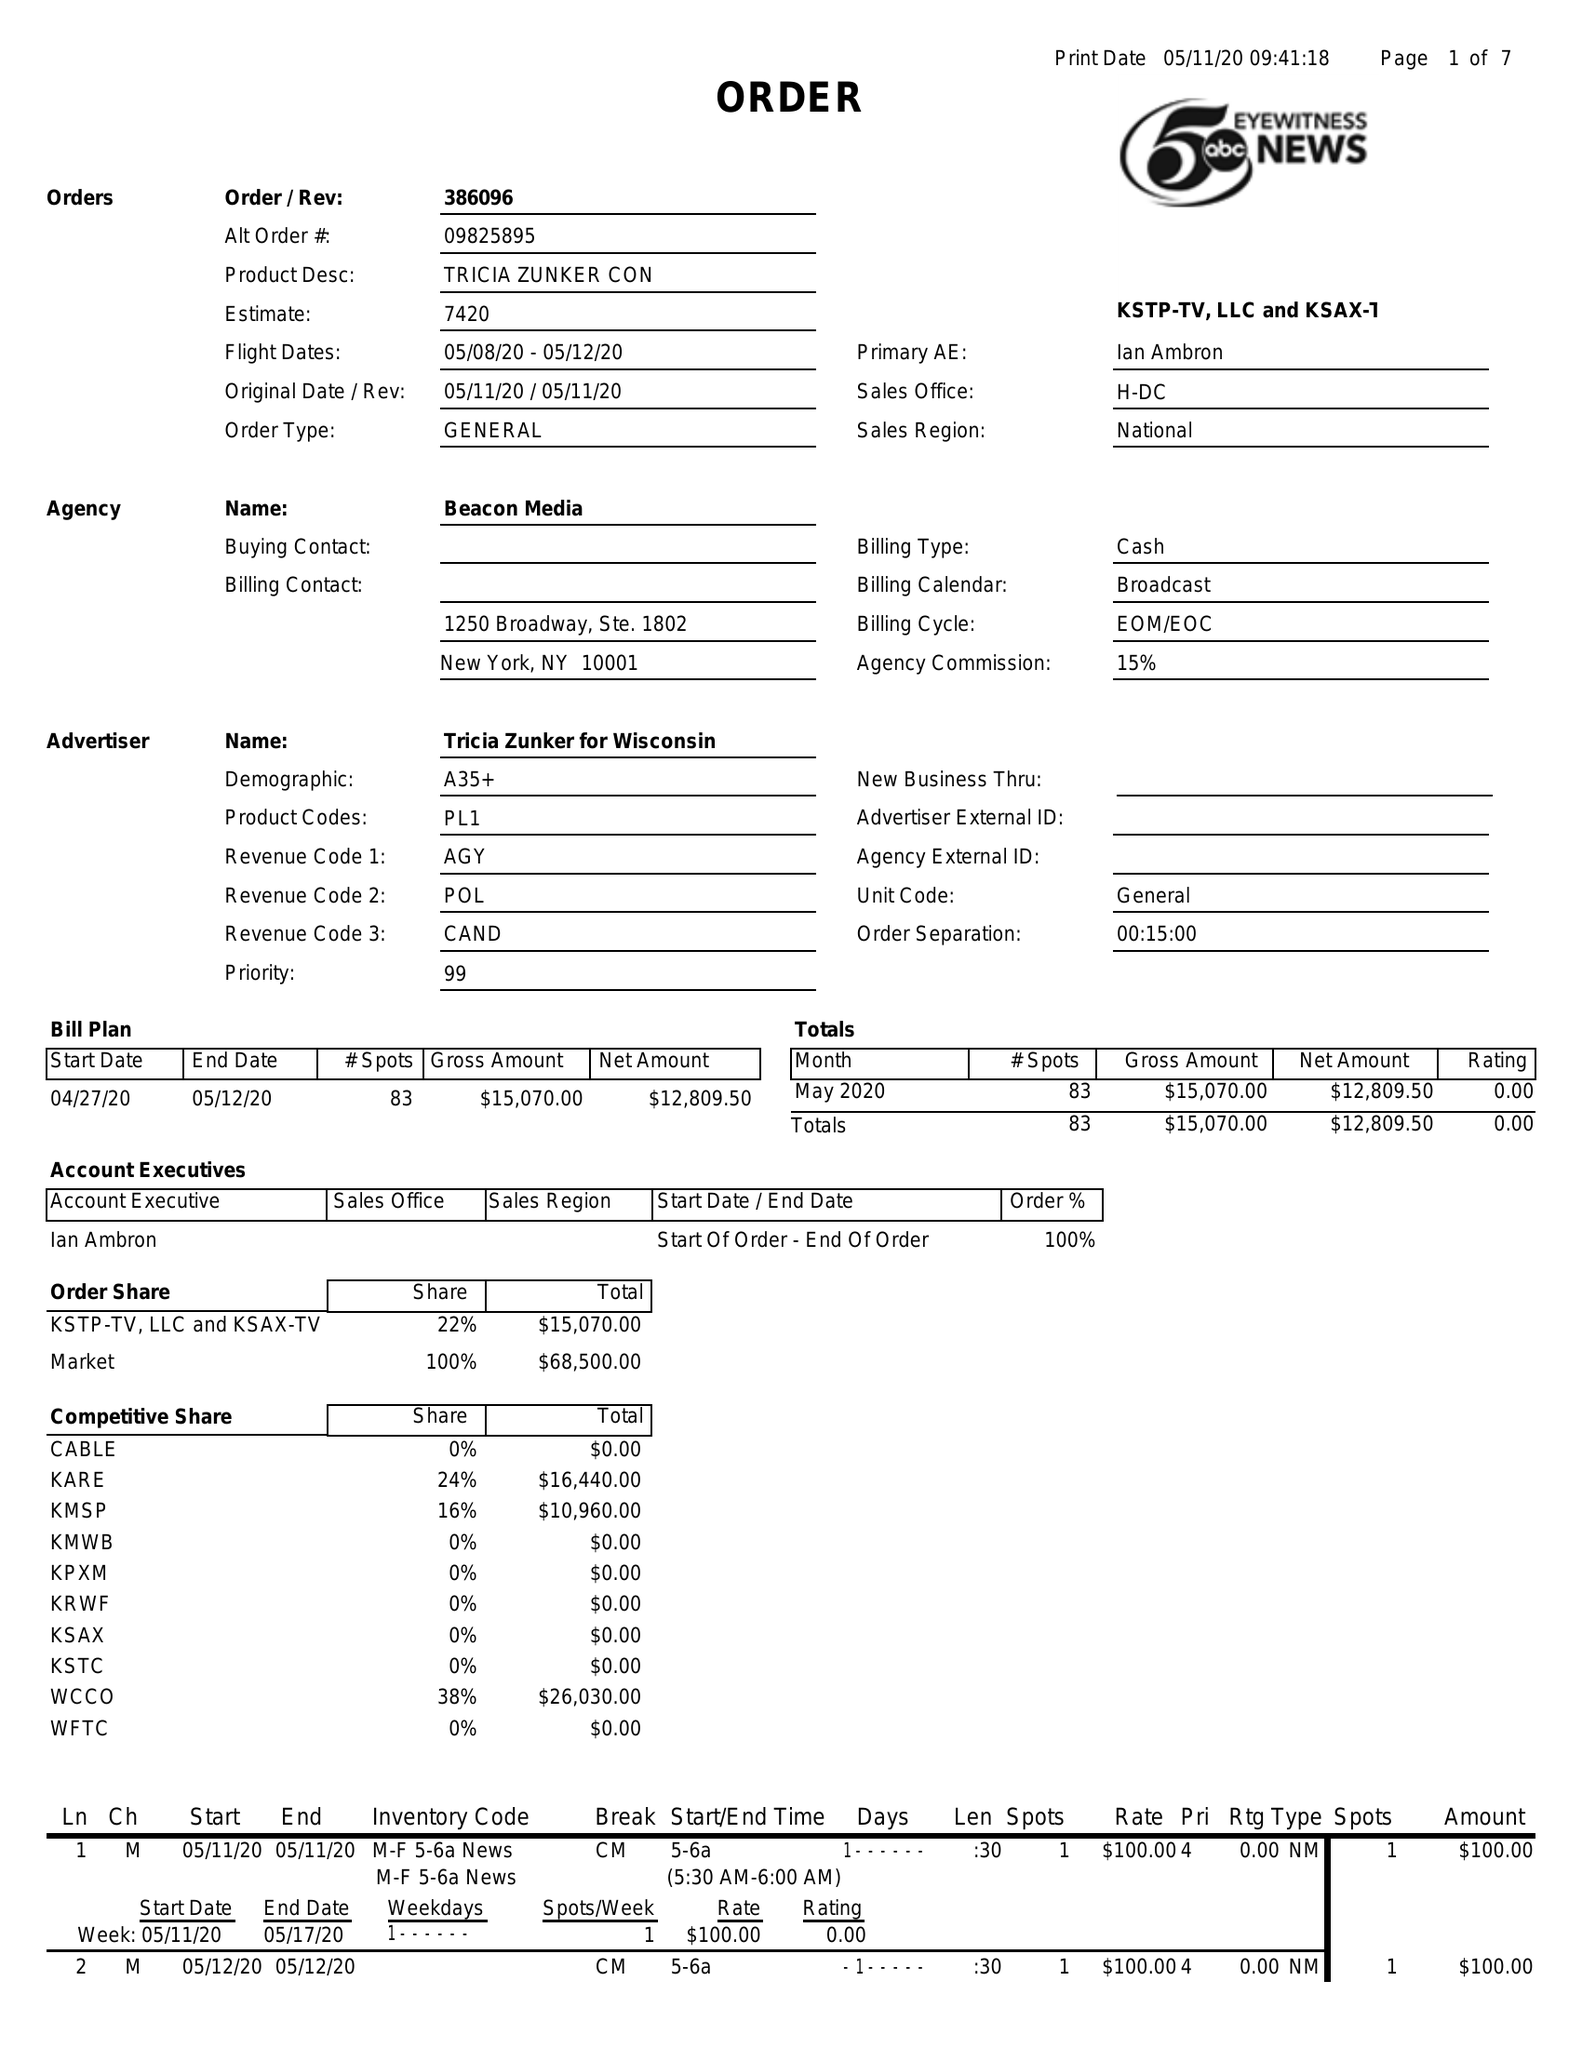What is the value for the advertiser?
Answer the question using a single word or phrase. TRICIA ZUNKER FOR WISCONSIN 